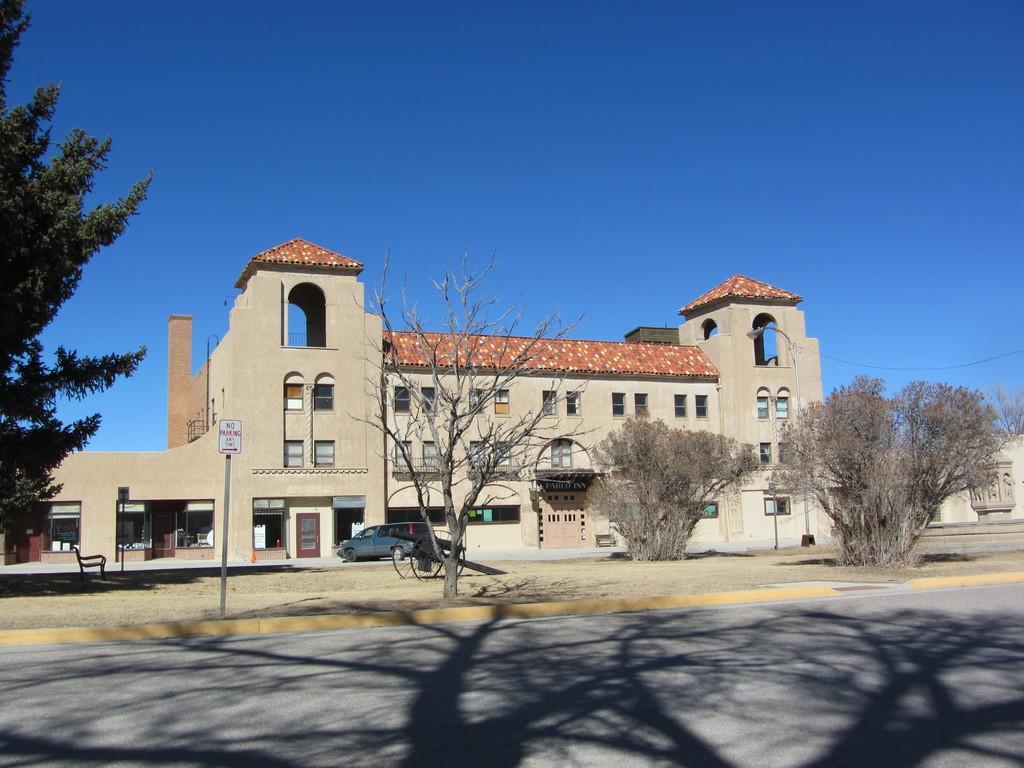Please provide a concise description of this image. In this picture we can see road, car, chair, trees, boards on poles and building. In the background of the image we can see the sky on blue color. 